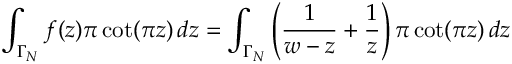<formula> <loc_0><loc_0><loc_500><loc_500>\int _ { \Gamma _ { N } } f ( z ) \pi \cot ( \pi z ) \, d z = \int _ { \Gamma _ { N } } \left ( { \frac { 1 } { w - z } } + { \frac { 1 } { z } } \right ) \pi \cot ( \pi z ) \, d z</formula> 